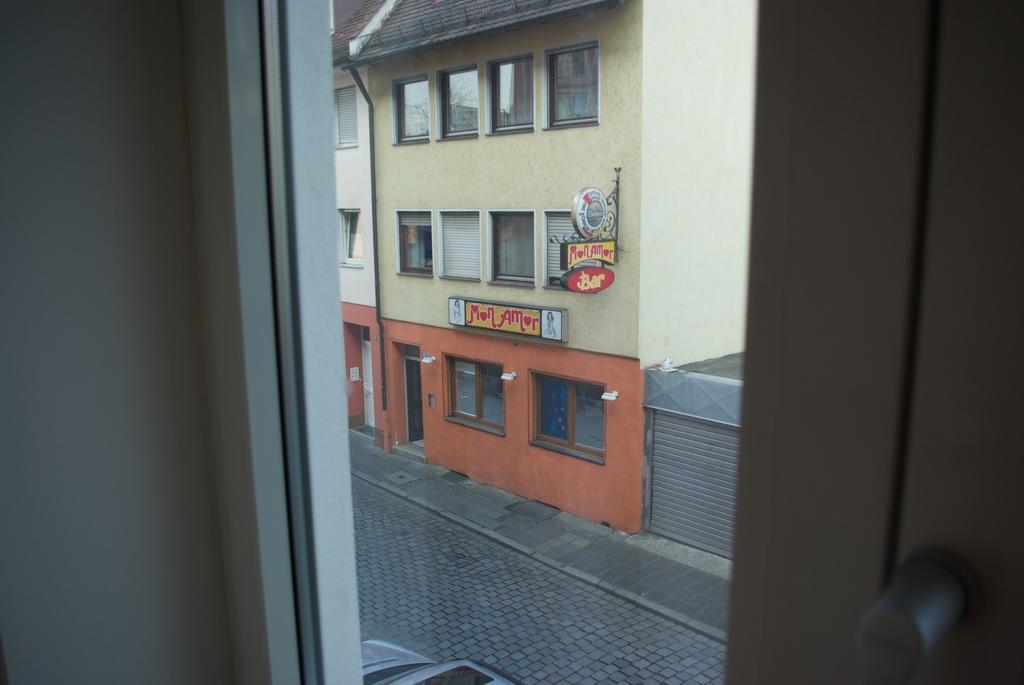Describe this image in one or two sentences. This picture is taken from a glass I can see buildings and couple of boards with text and a car. 